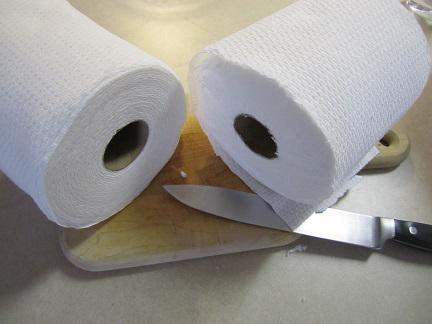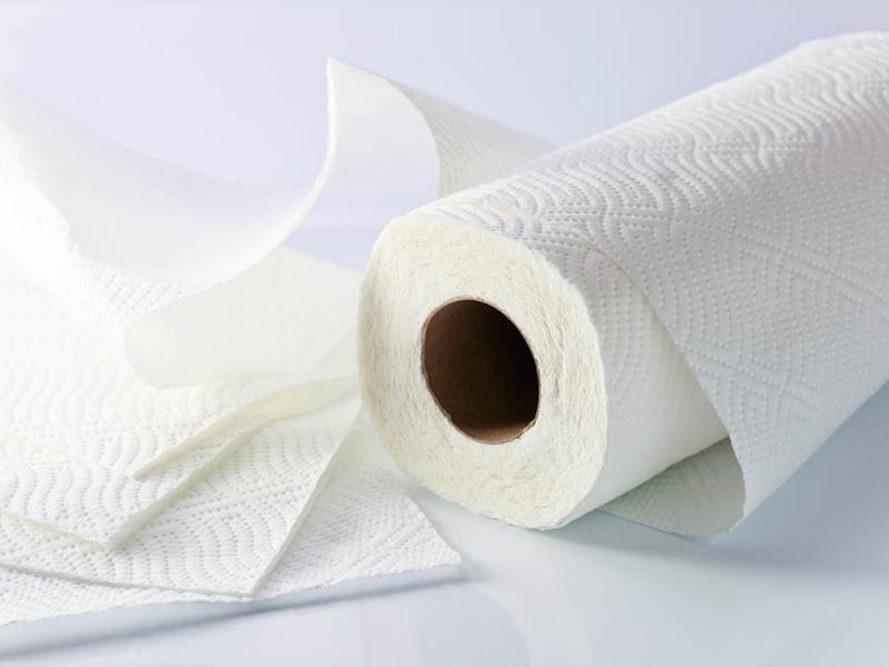The first image is the image on the left, the second image is the image on the right. Given the left and right images, does the statement "An image features some neatly stacked rolls of paper towels." hold true? Answer yes or no. No. The first image is the image on the left, the second image is the image on the right. Examine the images to the left and right. Is the description "Two paper towel rolls lie on a surface in one of the images." accurate? Answer yes or no. Yes. 